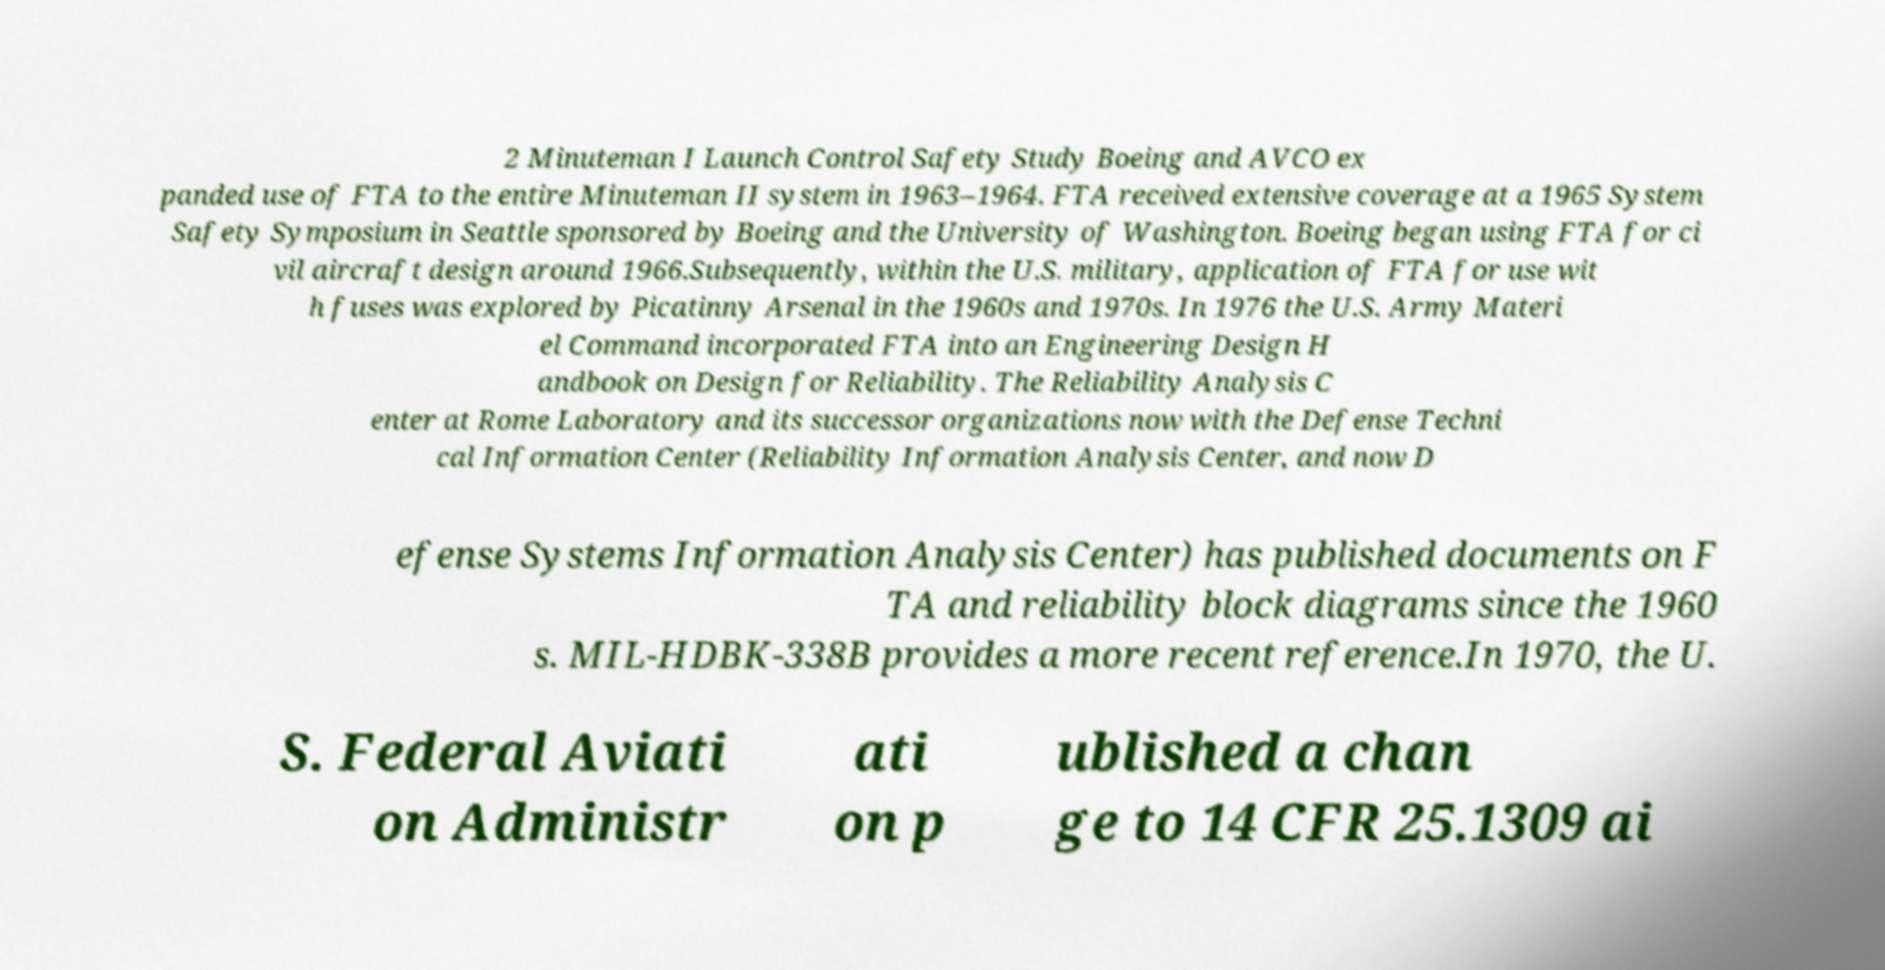I need the written content from this picture converted into text. Can you do that? 2 Minuteman I Launch Control Safety Study Boeing and AVCO ex panded use of FTA to the entire Minuteman II system in 1963–1964. FTA received extensive coverage at a 1965 System Safety Symposium in Seattle sponsored by Boeing and the University of Washington. Boeing began using FTA for ci vil aircraft design around 1966.Subsequently, within the U.S. military, application of FTA for use wit h fuses was explored by Picatinny Arsenal in the 1960s and 1970s. In 1976 the U.S. Army Materi el Command incorporated FTA into an Engineering Design H andbook on Design for Reliability. The Reliability Analysis C enter at Rome Laboratory and its successor organizations now with the Defense Techni cal Information Center (Reliability Information Analysis Center, and now D efense Systems Information Analysis Center) has published documents on F TA and reliability block diagrams since the 1960 s. MIL-HDBK-338B provides a more recent reference.In 1970, the U. S. Federal Aviati on Administr ati on p ublished a chan ge to 14 CFR 25.1309 ai 